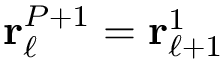<formula> <loc_0><loc_0><loc_500><loc_500>{ r } _ { \ell } ^ { P + 1 } = { r } _ { \ell + 1 } ^ { 1 }</formula> 